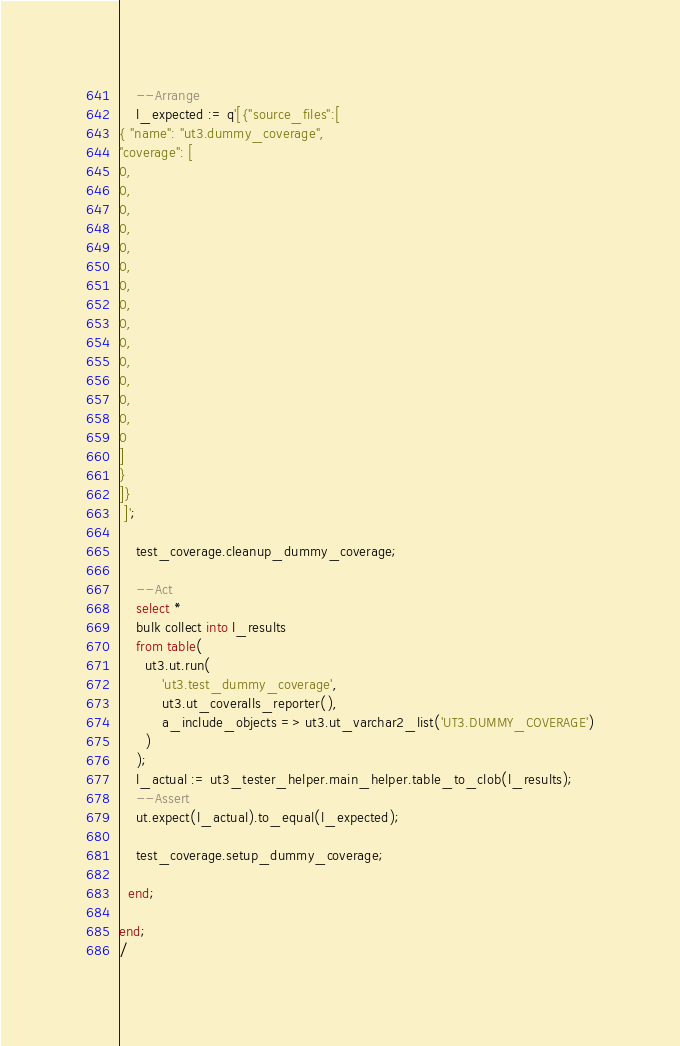<code> <loc_0><loc_0><loc_500><loc_500><_SQL_>    --Arrange
    l_expected := q'[{"source_files":[
{ "name": "ut3.dummy_coverage",
"coverage": [
0,
0,
0,
0,
0,
0,
0,
0,
0,
0,
0,
0,
0,
0,
0
]
}
]}
 ]';

    test_coverage.cleanup_dummy_coverage;

    --Act
    select *
    bulk collect into l_results
    from table(
      ut3.ut.run(
          'ut3.test_dummy_coverage',
          ut3.ut_coveralls_reporter(),
          a_include_objects => ut3.ut_varchar2_list('UT3.DUMMY_COVERAGE')
      )
    );
    l_actual := ut3_tester_helper.main_helper.table_to_clob(l_results);
    --Assert
    ut.expect(l_actual).to_equal(l_expected);

    test_coverage.setup_dummy_coverage;

  end;

end;
/
</code> 